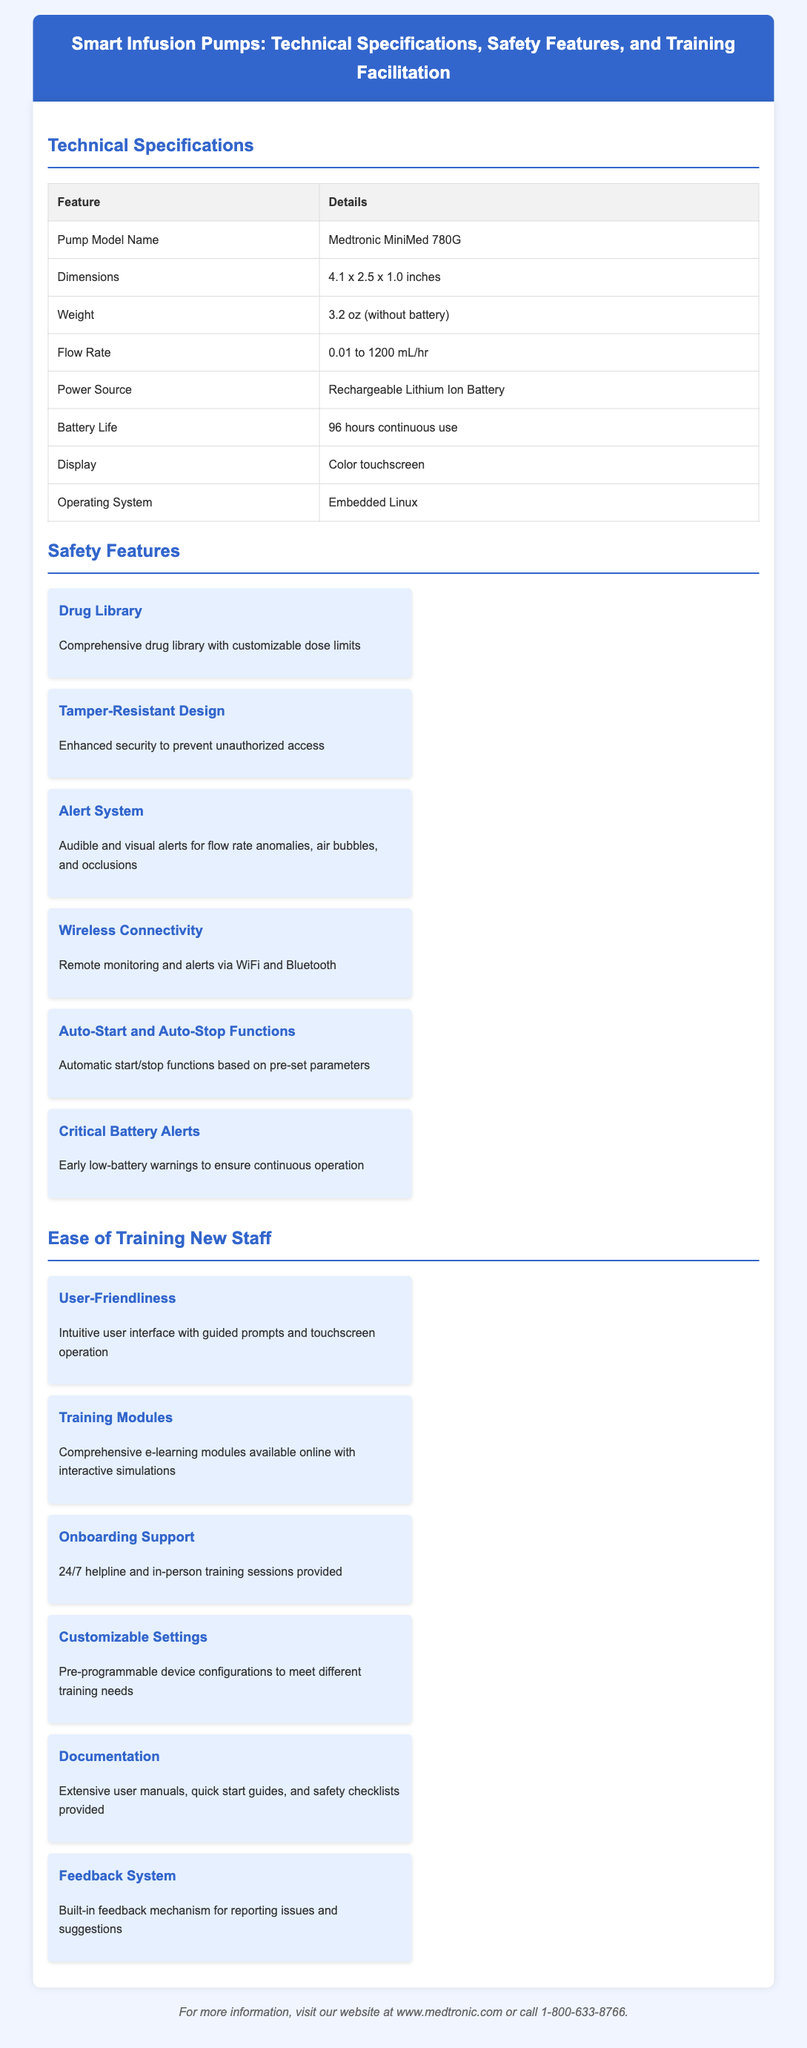What is the model name of the pump? The model name is found in the Technical Specifications section of the document.
Answer: Medtronic MiniMed 780G What is the weight of the pump? The weight is listed in the Technical Specifications section.
Answer: 3.2 oz (without battery) What alerts does the pump provide for flow rate anomalies? The details on alerts can be found in the Safety Features section under the Alert System.
Answer: Audible and visual alerts What is the battery life of the smart infusion pump? Battery life is mentioned in the Technical Specifications section.
Answer: 96 hours continuous use How does the device support training for new staff? The Ease of Training section elaborates on the available support options for new staff.
Answer: 24/7 helpline and in-person training sessions What type of display does the pump have? The display type is noted in the Technical Specifications section.
Answer: Color touchscreen What feature allows for customizable dose limits? This information can be found under the Safety Features section regarding the drug library.
Answer: Drug Library What allows for remote monitoring of the pump? The ability to monitor remotely is described in the Wireless Connectivity safety feature.
Answer: WiFi and Bluetooth What is a critical feature for low-battery warnings? This is specified in the Safety Features section under Critical Battery Alerts.
Answer: Early low-battery warnings 